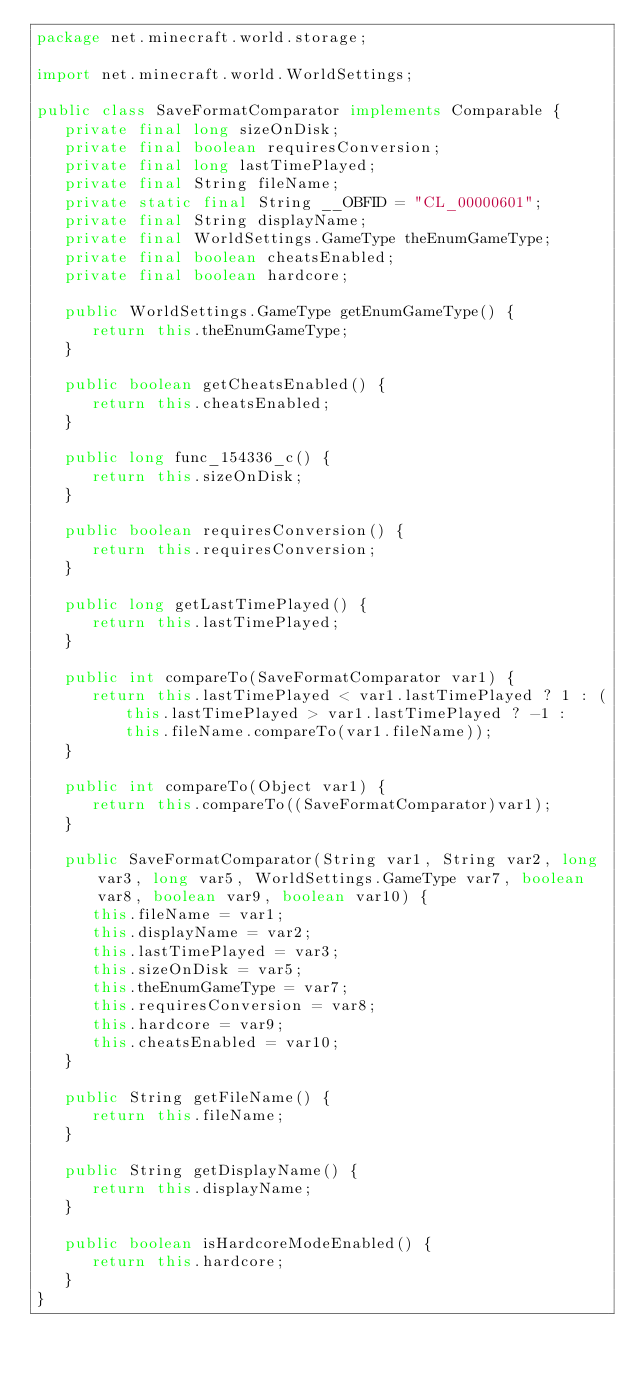<code> <loc_0><loc_0><loc_500><loc_500><_Java_>package net.minecraft.world.storage;

import net.minecraft.world.WorldSettings;

public class SaveFormatComparator implements Comparable {
   private final long sizeOnDisk;
   private final boolean requiresConversion;
   private final long lastTimePlayed;
   private final String fileName;
   private static final String __OBFID = "CL_00000601";
   private final String displayName;
   private final WorldSettings.GameType theEnumGameType;
   private final boolean cheatsEnabled;
   private final boolean hardcore;

   public WorldSettings.GameType getEnumGameType() {
      return this.theEnumGameType;
   }

   public boolean getCheatsEnabled() {
      return this.cheatsEnabled;
   }

   public long func_154336_c() {
      return this.sizeOnDisk;
   }

   public boolean requiresConversion() {
      return this.requiresConversion;
   }

   public long getLastTimePlayed() {
      return this.lastTimePlayed;
   }

   public int compareTo(SaveFormatComparator var1) {
      return this.lastTimePlayed < var1.lastTimePlayed ? 1 : (this.lastTimePlayed > var1.lastTimePlayed ? -1 : this.fileName.compareTo(var1.fileName));
   }

   public int compareTo(Object var1) {
      return this.compareTo((SaveFormatComparator)var1);
   }

   public SaveFormatComparator(String var1, String var2, long var3, long var5, WorldSettings.GameType var7, boolean var8, boolean var9, boolean var10) {
      this.fileName = var1;
      this.displayName = var2;
      this.lastTimePlayed = var3;
      this.sizeOnDisk = var5;
      this.theEnumGameType = var7;
      this.requiresConversion = var8;
      this.hardcore = var9;
      this.cheatsEnabled = var10;
   }

   public String getFileName() {
      return this.fileName;
   }

   public String getDisplayName() {
      return this.displayName;
   }

   public boolean isHardcoreModeEnabled() {
      return this.hardcore;
   }
}
</code> 